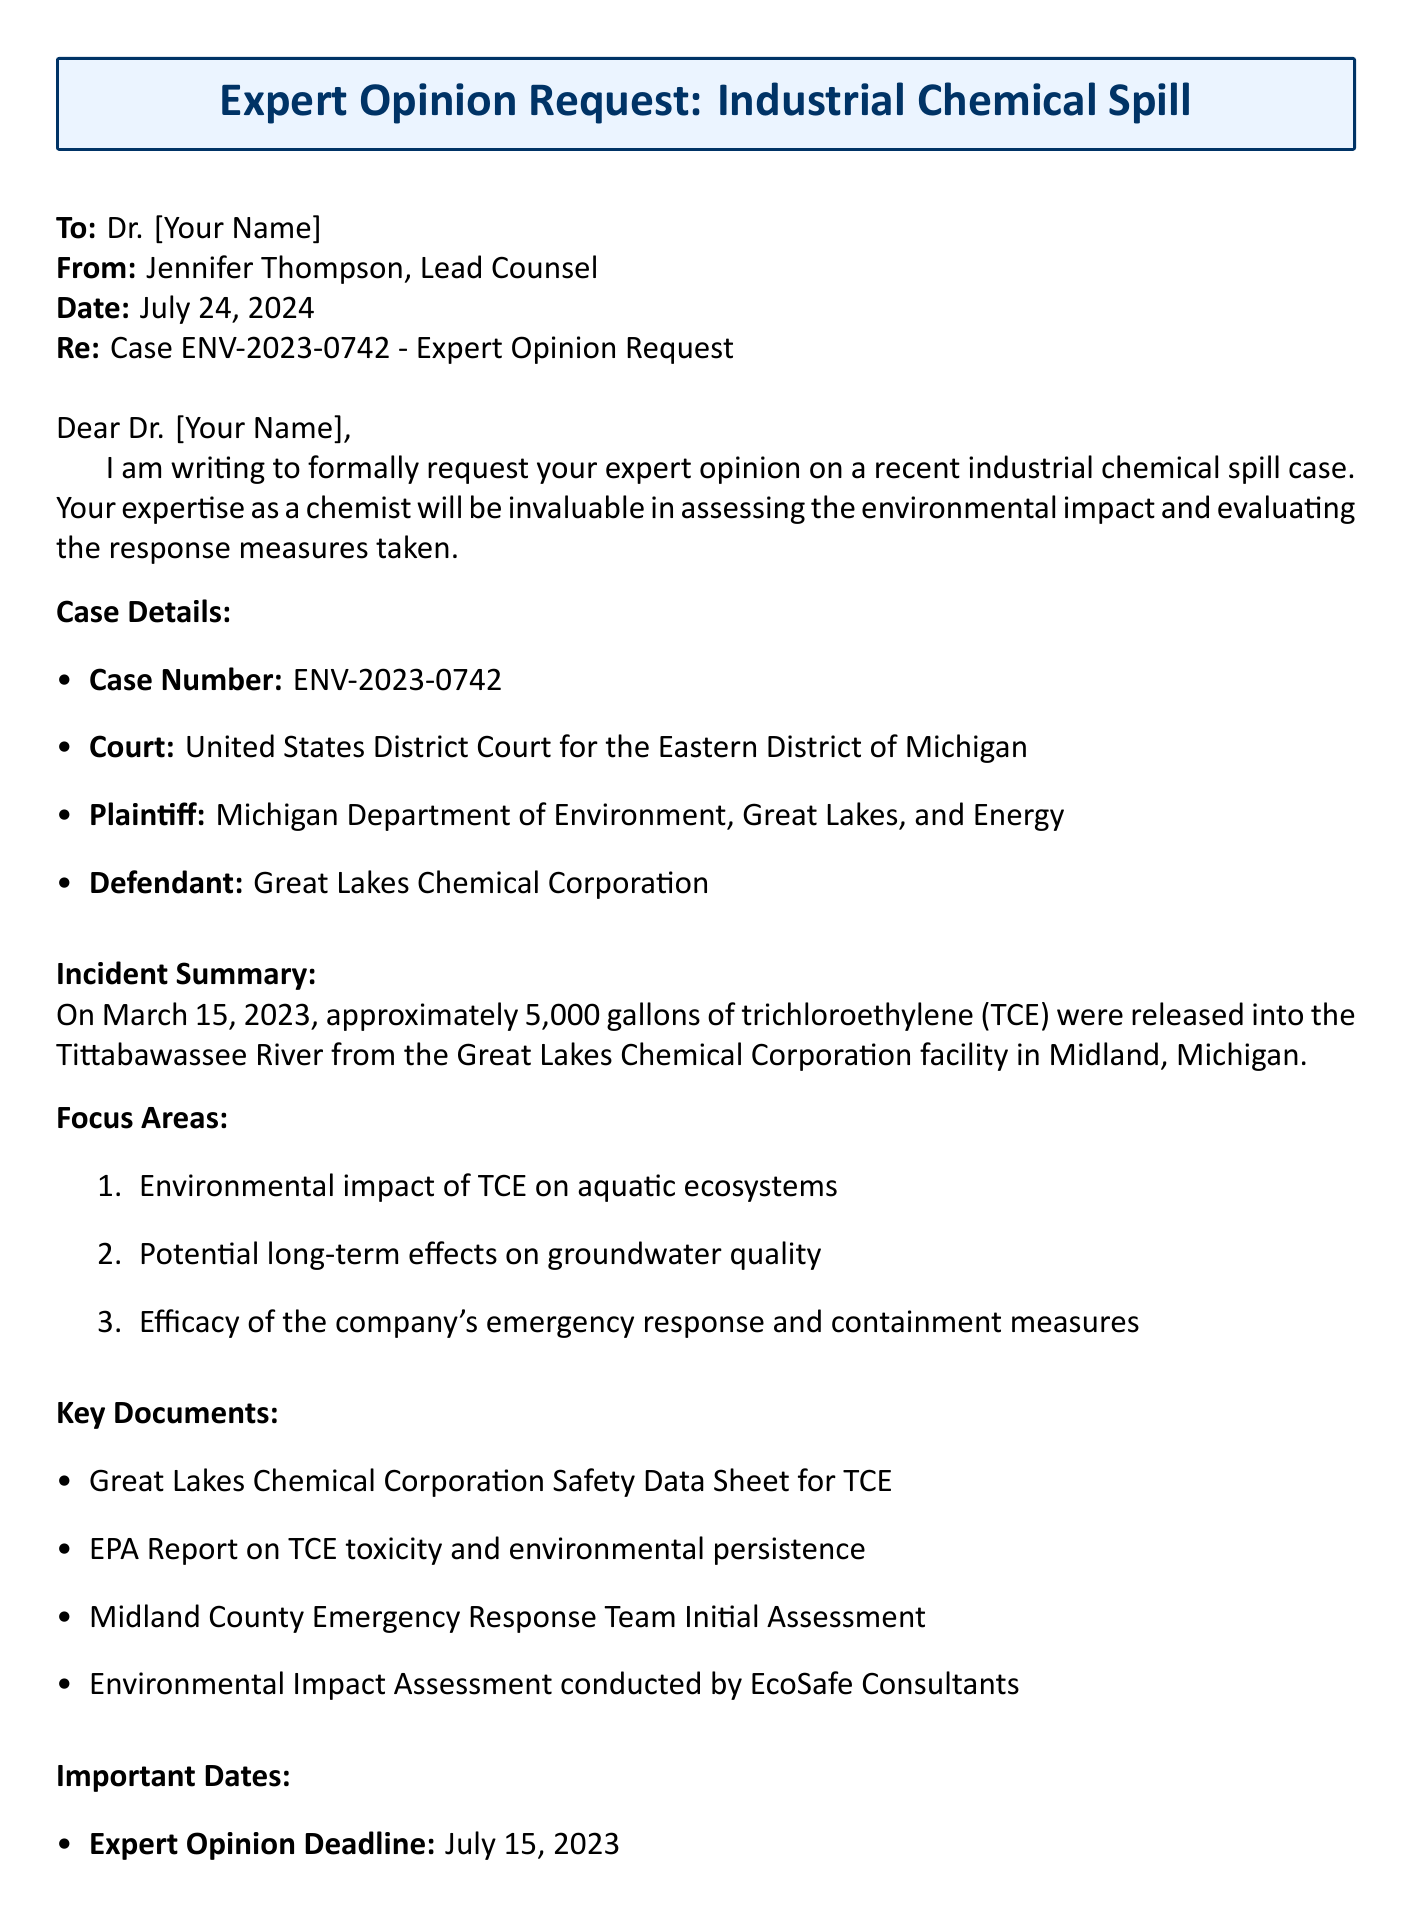What is the case number? The case number is explicitly mentioned in the document as ENV-2023-0742.
Answer: ENV-2023-0742 Who is the plaintiff in this case? The plaintiff is identified in the document as the Michigan Department of Environment, Great Lakes, and Energy.
Answer: Michigan Department of Environment, Great Lakes, and Energy What substance was released during the chemical spill? The substance released during the spill, as stated in the incident summary, is trichloroethylene (TCE).
Answer: trichloroethylene (TCE) What is the deadline for the expert opinion? The deadline for the expert opinion, as specified in the document, is July 15, 2023.
Answer: July 15, 2023 On what date will the expert testimony take place? The date for the expert testimony is provided in the section on important dates as September 12, 2023.
Answer: September 12, 2023 What key document relates to TCE toxicity? The document lists the EPA Report on TCE toxicity and environmental persistence as a key document.
Answer: EPA Report on TCE toxicity and environmental persistence What is the focus area regarding aquatic ecosystems? The focus area specifically addressing aquatic ecosystems is the environmental impact of TCE on aquatic ecosystems.
Answer: Environmental impact of TCE on aquatic ecosystems Who sent the email? The sender of the email is Jennifer Thompson, who is identified as the Lead Counsel.
Answer: Jennifer Thompson What court is handling this case? The document specifies that the case is being handled by the United States District Court for the Eastern District of Michigan.
Answer: United States District Court for the Eastern District of Michigan 